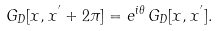<formula> <loc_0><loc_0><loc_500><loc_500>G _ { D } [ x , x ^ { ^ { \prime } } + 2 \pi ] = e ^ { i \theta } \, G _ { D } [ x , x ^ { ^ { \prime } } ] .</formula> 